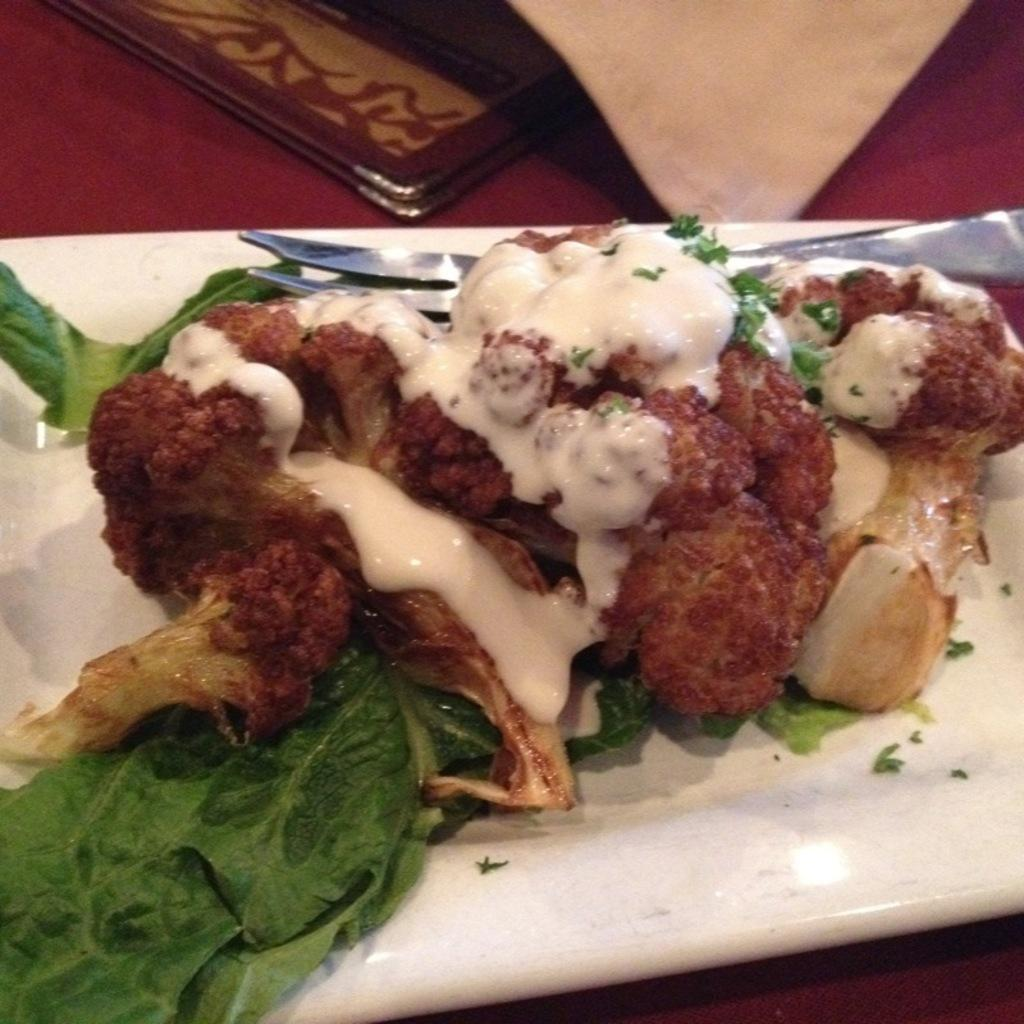What type of food is visible in the image? There is food with green leaves in the image. How is the food presented? The food is on a white plate. Where is the plate located? The plate is placed on a table top. What else can be seen on the table? There is a menu card in the image. What type of fear is expressed by the food in the image? The food does not express any fear in the image, as it is an inanimate object. 